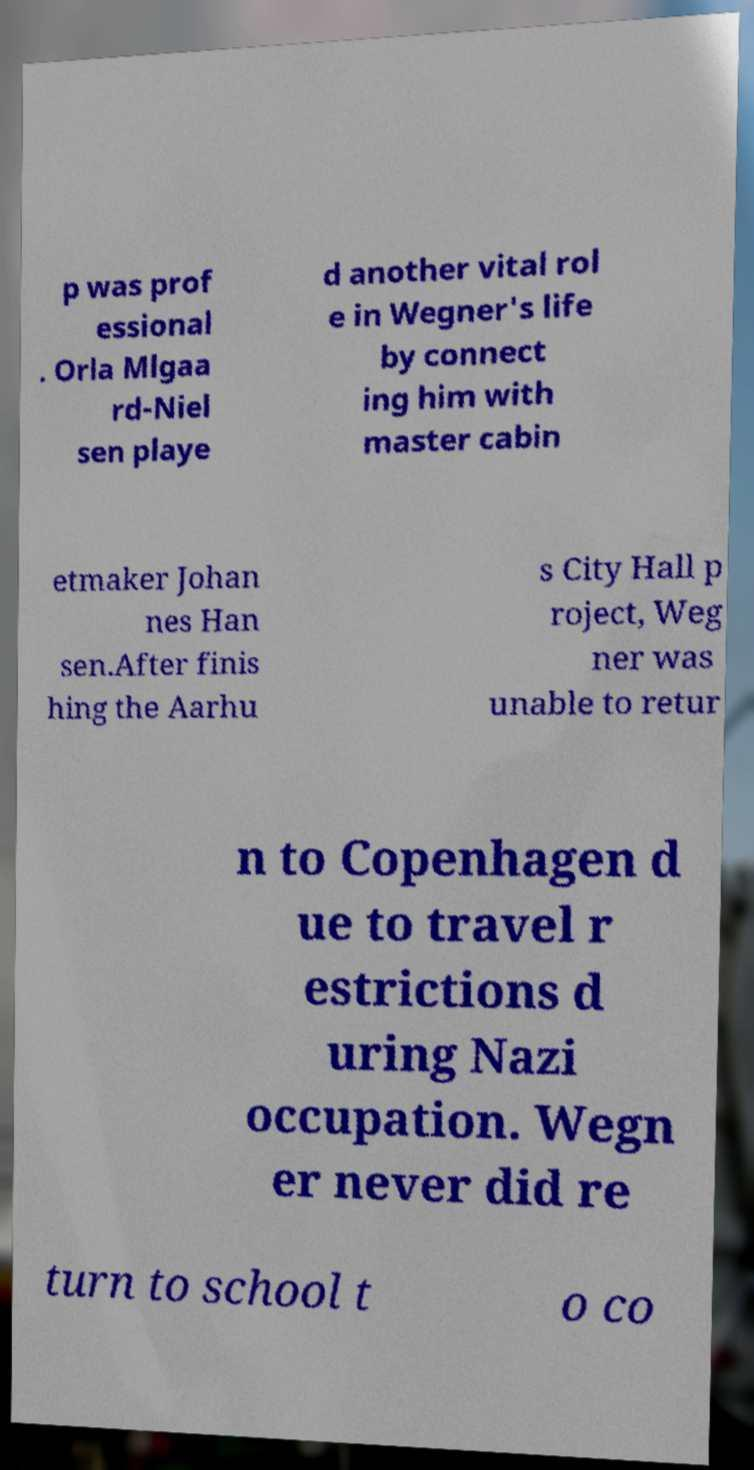There's text embedded in this image that I need extracted. Can you transcribe it verbatim? p was prof essional . Orla Mlgaa rd-Niel sen playe d another vital rol e in Wegner's life by connect ing him with master cabin etmaker Johan nes Han sen.After finis hing the Aarhu s City Hall p roject, Weg ner was unable to retur n to Copenhagen d ue to travel r estrictions d uring Nazi occupation. Wegn er never did re turn to school t o co 